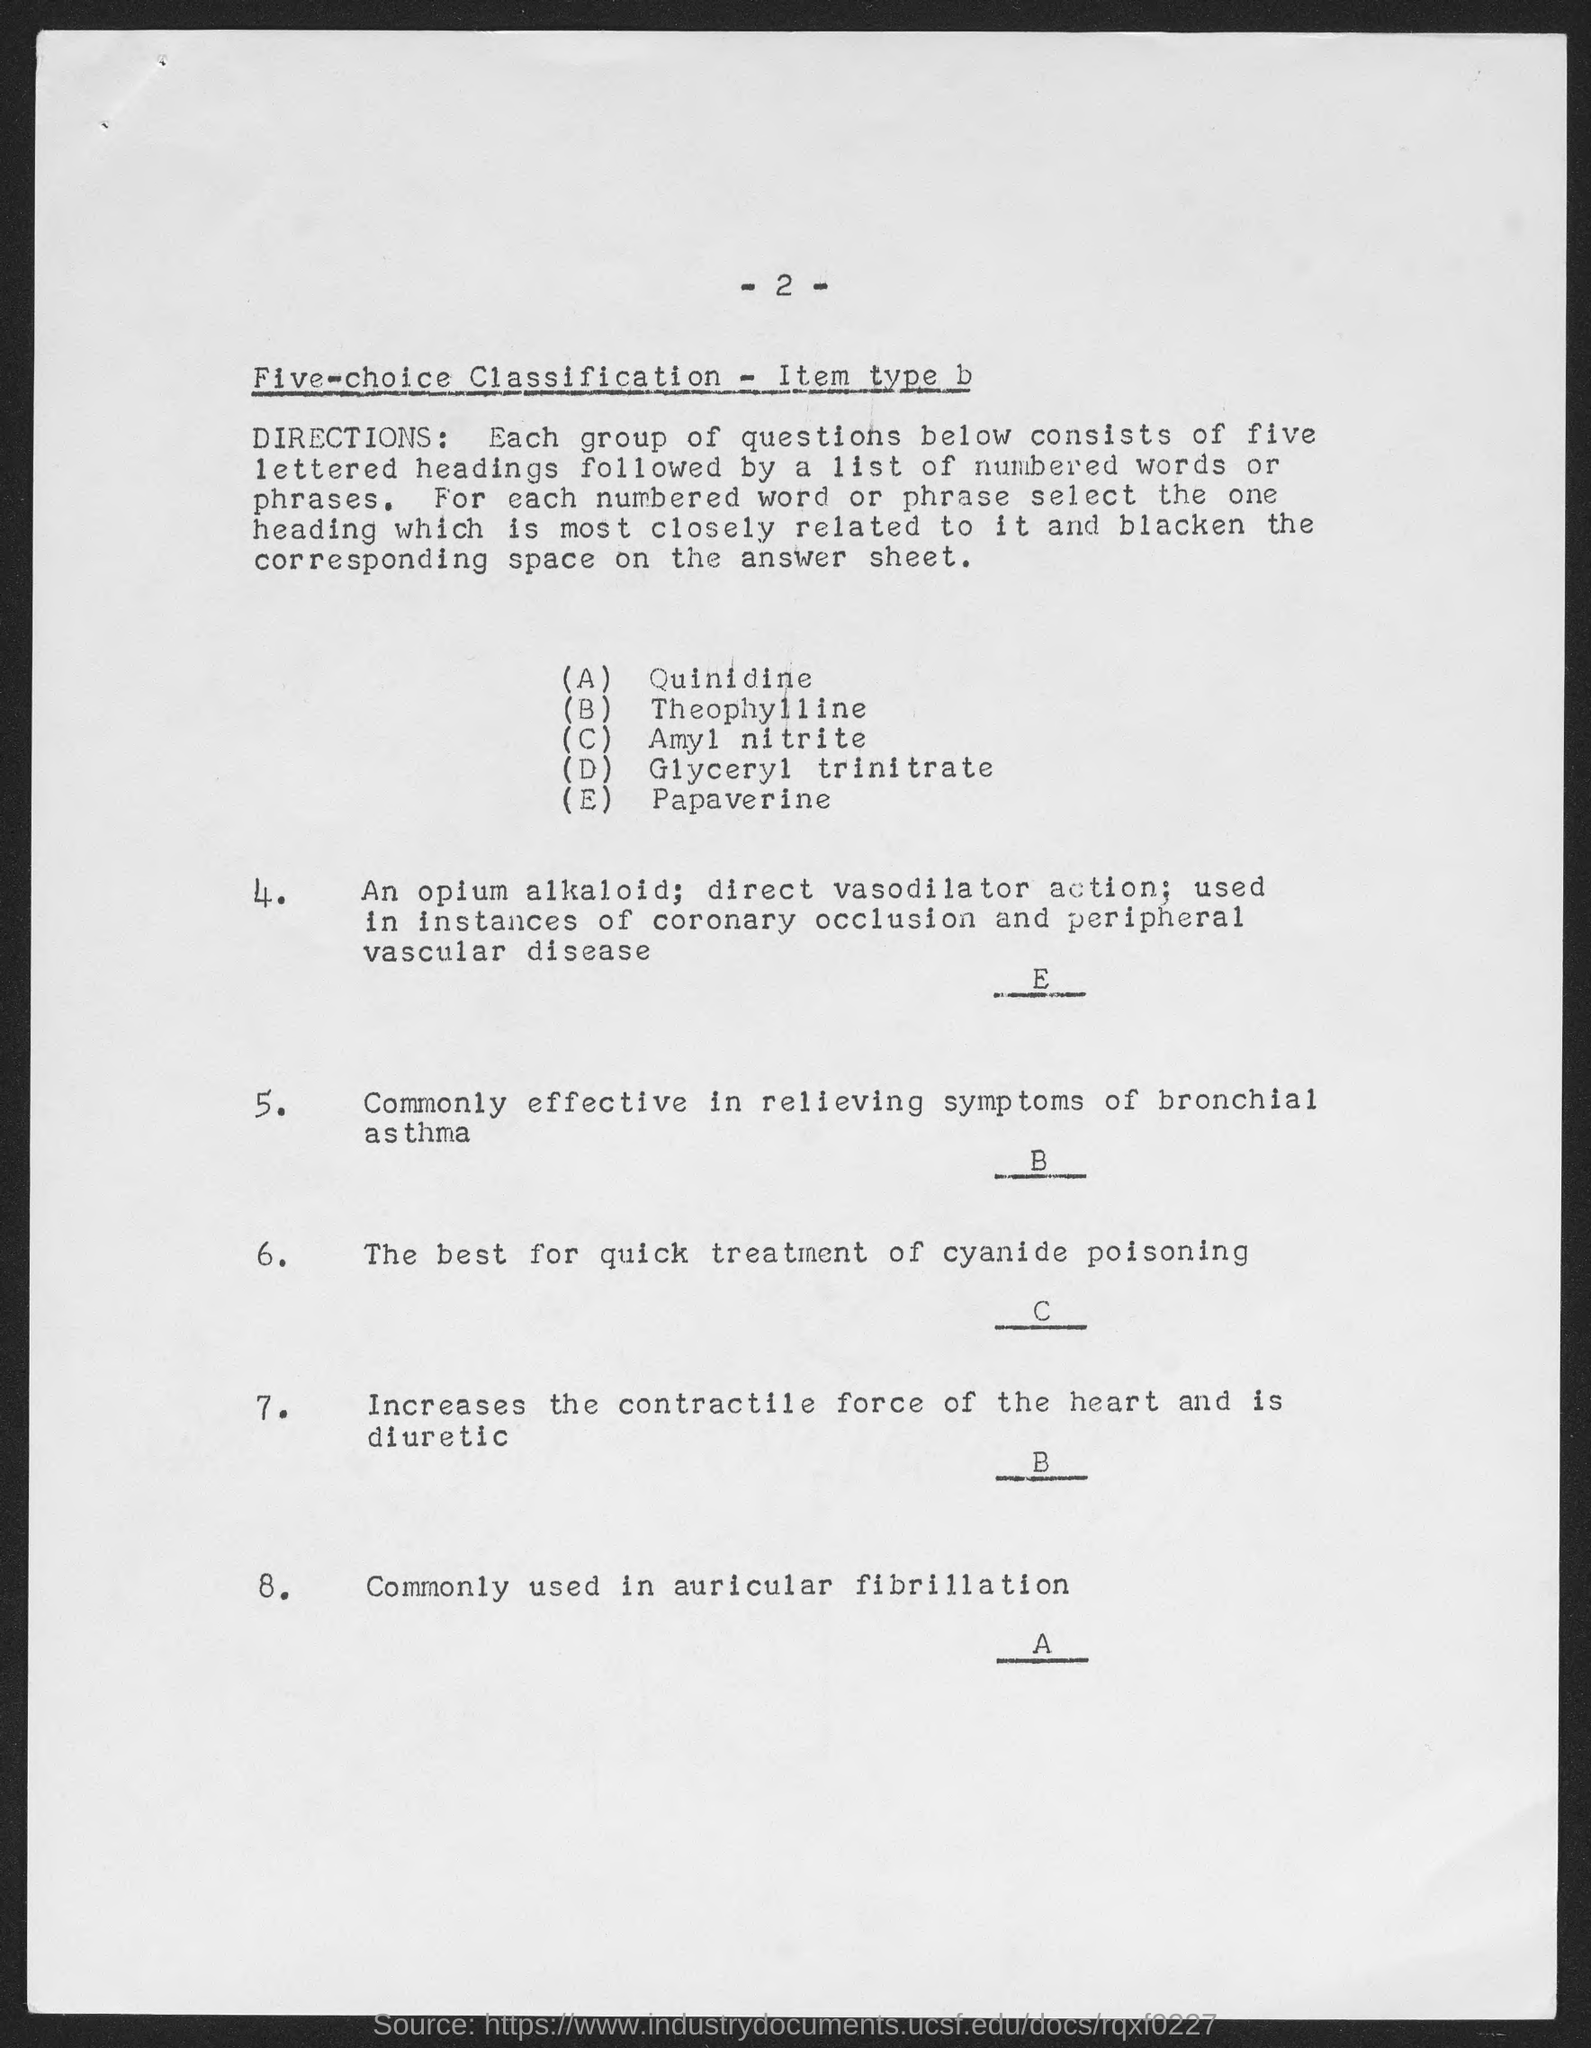Indicate a few pertinent items in this graphic. The letter 'D' represents the heading "Glyceryl trinitrate" in the given text. The page number mentioned in the top of the document is -2-. The first lettered heading shown in the document is "Quinidine. The heading represented by the letter 'A' is "QUINIDINE". Papaverine is the heading represented by the letter 'E'. 